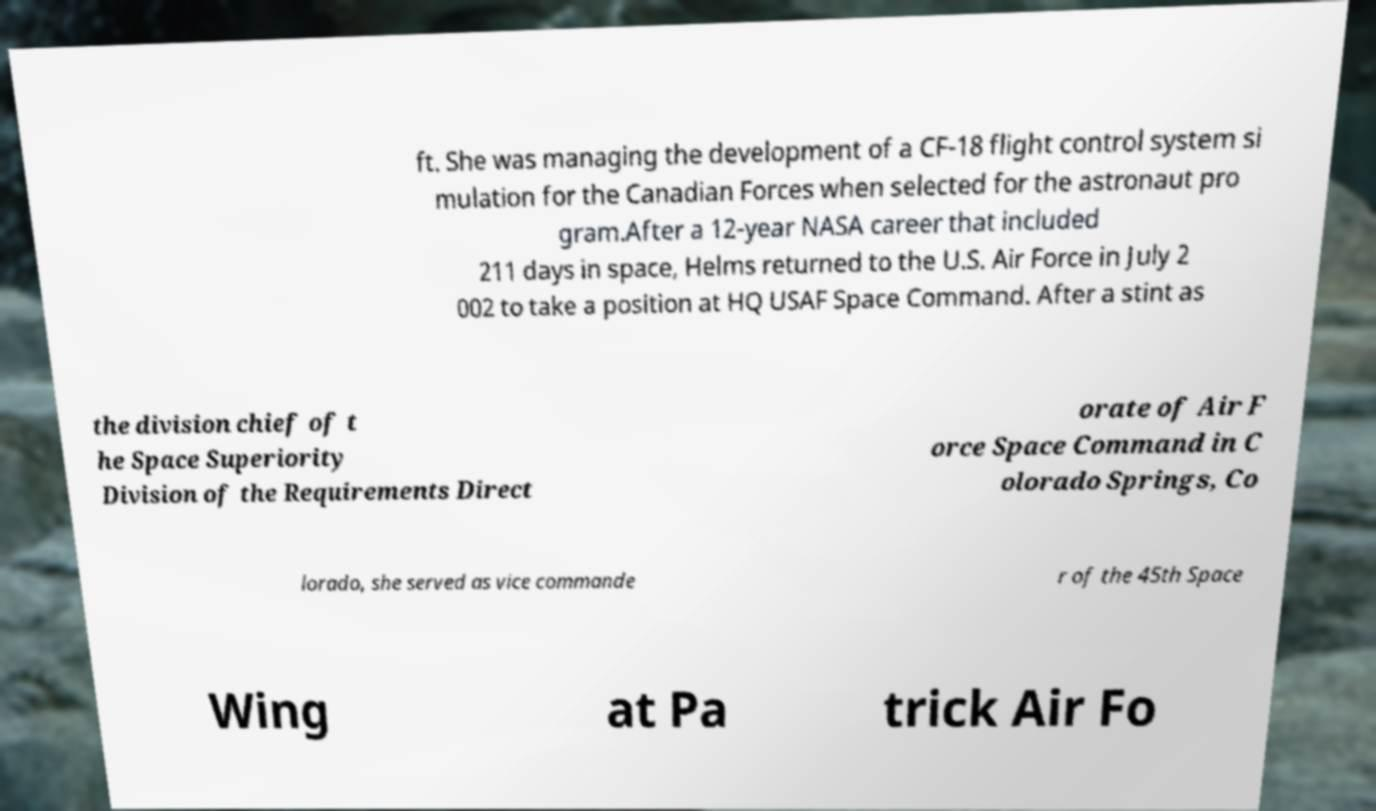Please read and relay the text visible in this image. What does it say? ft. She was managing the development of a CF-18 flight control system si mulation for the Canadian Forces when selected for the astronaut pro gram.After a 12-year NASA career that included 211 days in space, Helms returned to the U.S. Air Force in July 2 002 to take a position at HQ USAF Space Command. After a stint as the division chief of t he Space Superiority Division of the Requirements Direct orate of Air F orce Space Command in C olorado Springs, Co lorado, she served as vice commande r of the 45th Space Wing at Pa trick Air Fo 